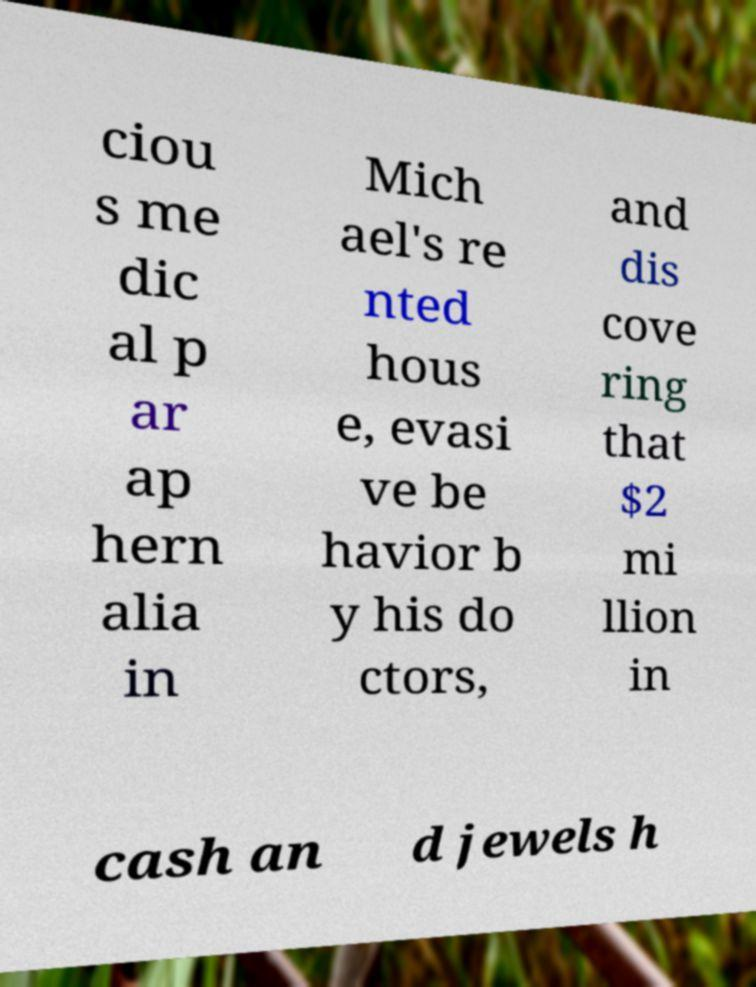I need the written content from this picture converted into text. Can you do that? ciou s me dic al p ar ap hern alia in Mich ael's re nted hous e, evasi ve be havior b y his do ctors, and dis cove ring that $2 mi llion in cash an d jewels h 